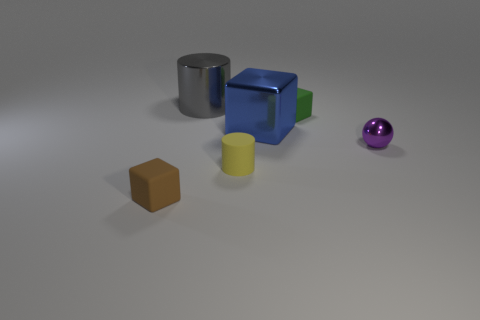Subtract all small blocks. How many blocks are left? 1 Subtract all brown blocks. How many blocks are left? 2 Subtract all cylinders. How many objects are left? 4 Subtract 1 spheres. How many spheres are left? 0 Subtract all blue spheres. Subtract all gray cylinders. How many spheres are left? 1 Subtract all yellow spheres. How many green cubes are left? 1 Subtract all tiny red rubber cylinders. Subtract all big blue metal objects. How many objects are left? 5 Add 6 big cylinders. How many big cylinders are left? 7 Add 4 small gray metallic cylinders. How many small gray metallic cylinders exist? 4 Add 1 cylinders. How many objects exist? 7 